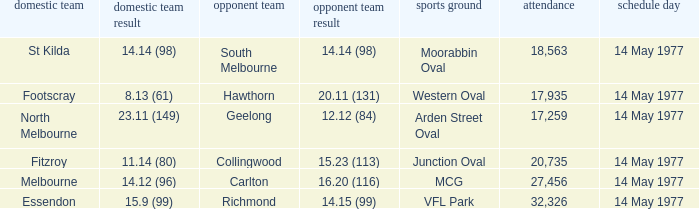Name the away team for essendon Richmond. 